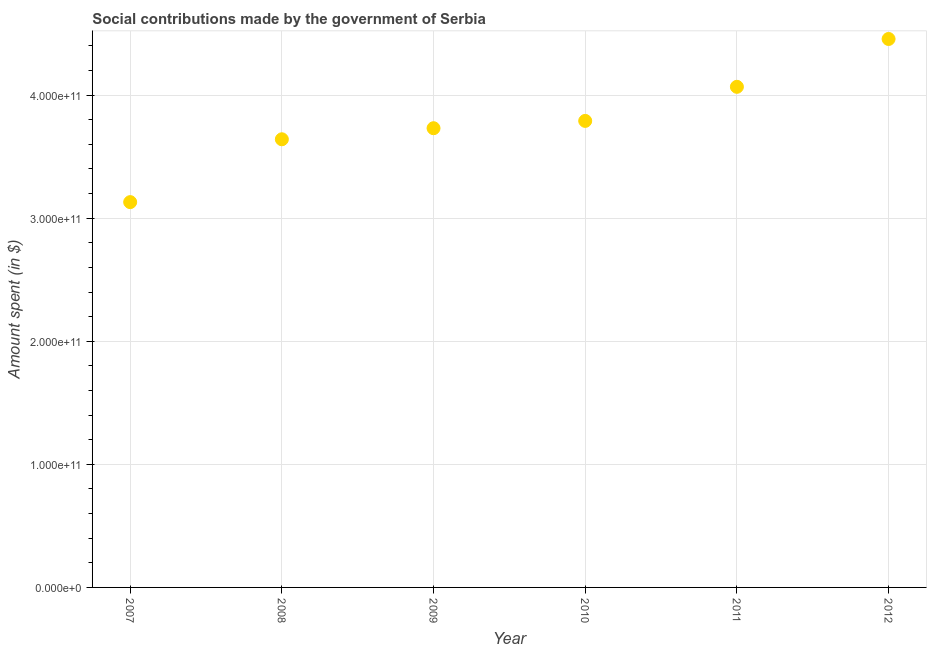What is the amount spent in making social contributions in 2009?
Keep it short and to the point. 3.73e+11. Across all years, what is the maximum amount spent in making social contributions?
Provide a succinct answer. 4.46e+11. Across all years, what is the minimum amount spent in making social contributions?
Offer a terse response. 3.13e+11. In which year was the amount spent in making social contributions maximum?
Provide a short and direct response. 2012. What is the sum of the amount spent in making social contributions?
Offer a terse response. 2.28e+12. What is the difference between the amount spent in making social contributions in 2008 and 2009?
Your answer should be compact. -8.99e+09. What is the average amount spent in making social contributions per year?
Your answer should be compact. 3.80e+11. What is the median amount spent in making social contributions?
Offer a terse response. 3.76e+11. In how many years, is the amount spent in making social contributions greater than 100000000000 $?
Make the answer very short. 6. What is the ratio of the amount spent in making social contributions in 2010 to that in 2011?
Keep it short and to the point. 0.93. What is the difference between the highest and the second highest amount spent in making social contributions?
Your answer should be compact. 3.89e+1. What is the difference between the highest and the lowest amount spent in making social contributions?
Ensure brevity in your answer.  1.33e+11. Does the amount spent in making social contributions monotonically increase over the years?
Give a very brief answer. Yes. How many years are there in the graph?
Your answer should be very brief. 6. What is the difference between two consecutive major ticks on the Y-axis?
Your response must be concise. 1.00e+11. Does the graph contain any zero values?
Keep it short and to the point. No. What is the title of the graph?
Make the answer very short. Social contributions made by the government of Serbia. What is the label or title of the X-axis?
Your answer should be very brief. Year. What is the label or title of the Y-axis?
Provide a short and direct response. Amount spent (in $). What is the Amount spent (in $) in 2007?
Ensure brevity in your answer.  3.13e+11. What is the Amount spent (in $) in 2008?
Your answer should be compact. 3.64e+11. What is the Amount spent (in $) in 2009?
Provide a short and direct response. 3.73e+11. What is the Amount spent (in $) in 2010?
Provide a short and direct response. 3.79e+11. What is the Amount spent (in $) in 2011?
Make the answer very short. 4.07e+11. What is the Amount spent (in $) in 2012?
Your answer should be compact. 4.46e+11. What is the difference between the Amount spent (in $) in 2007 and 2008?
Provide a succinct answer. -5.11e+1. What is the difference between the Amount spent (in $) in 2007 and 2009?
Keep it short and to the point. -6.00e+1. What is the difference between the Amount spent (in $) in 2007 and 2010?
Your answer should be very brief. -6.60e+1. What is the difference between the Amount spent (in $) in 2007 and 2011?
Keep it short and to the point. -9.37e+1. What is the difference between the Amount spent (in $) in 2007 and 2012?
Provide a succinct answer. -1.33e+11. What is the difference between the Amount spent (in $) in 2008 and 2009?
Give a very brief answer. -8.99e+09. What is the difference between the Amount spent (in $) in 2008 and 2010?
Make the answer very short. -1.49e+1. What is the difference between the Amount spent (in $) in 2008 and 2011?
Your answer should be very brief. -4.26e+1. What is the difference between the Amount spent (in $) in 2008 and 2012?
Offer a very short reply. -8.15e+1. What is the difference between the Amount spent (in $) in 2009 and 2010?
Give a very brief answer. -5.94e+09. What is the difference between the Amount spent (in $) in 2009 and 2011?
Provide a succinct answer. -3.36e+1. What is the difference between the Amount spent (in $) in 2009 and 2012?
Make the answer very short. -7.25e+1. What is the difference between the Amount spent (in $) in 2010 and 2011?
Offer a terse response. -2.77e+1. What is the difference between the Amount spent (in $) in 2010 and 2012?
Offer a terse response. -6.66e+1. What is the difference between the Amount spent (in $) in 2011 and 2012?
Provide a succinct answer. -3.89e+1. What is the ratio of the Amount spent (in $) in 2007 to that in 2008?
Ensure brevity in your answer.  0.86. What is the ratio of the Amount spent (in $) in 2007 to that in 2009?
Your answer should be compact. 0.84. What is the ratio of the Amount spent (in $) in 2007 to that in 2010?
Your answer should be compact. 0.83. What is the ratio of the Amount spent (in $) in 2007 to that in 2011?
Offer a terse response. 0.77. What is the ratio of the Amount spent (in $) in 2007 to that in 2012?
Your response must be concise. 0.7. What is the ratio of the Amount spent (in $) in 2008 to that in 2009?
Provide a succinct answer. 0.98. What is the ratio of the Amount spent (in $) in 2008 to that in 2011?
Keep it short and to the point. 0.9. What is the ratio of the Amount spent (in $) in 2008 to that in 2012?
Provide a succinct answer. 0.82. What is the ratio of the Amount spent (in $) in 2009 to that in 2010?
Give a very brief answer. 0.98. What is the ratio of the Amount spent (in $) in 2009 to that in 2011?
Offer a very short reply. 0.92. What is the ratio of the Amount spent (in $) in 2009 to that in 2012?
Offer a very short reply. 0.84. What is the ratio of the Amount spent (in $) in 2010 to that in 2011?
Provide a short and direct response. 0.93. What is the ratio of the Amount spent (in $) in 2010 to that in 2012?
Offer a very short reply. 0.85. What is the ratio of the Amount spent (in $) in 2011 to that in 2012?
Offer a terse response. 0.91. 